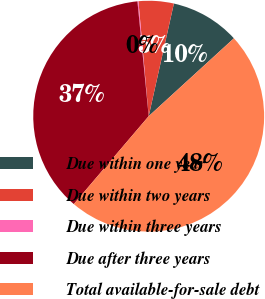Convert chart to OTSL. <chart><loc_0><loc_0><loc_500><loc_500><pie_chart><fcel>Due within one year<fcel>Due within two years<fcel>Due within three years<fcel>Due after three years<fcel>Total available-for-sale debt<nl><fcel>9.71%<fcel>4.92%<fcel>0.14%<fcel>37.21%<fcel>48.02%<nl></chart> 